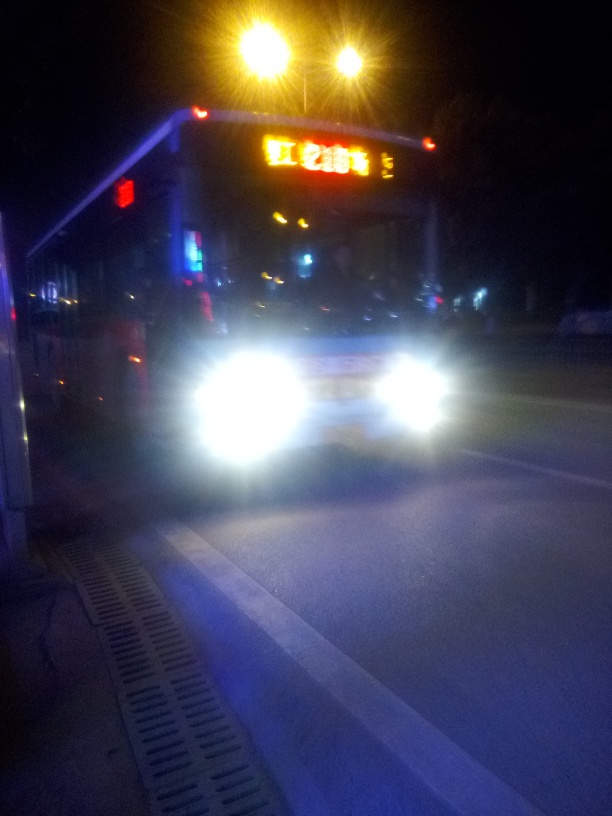Can you suggest ways this photo could have been improved? To improve the quality of this photo, a faster shutter speed could have been used to reduce motion blur. Increasing the camera's ISO setting might also help by allowing for a quicker exposure, though at the risk of more noise in the image. Additionally, steadying the camera, possibly with a tripod or by resting it on a stable surface, would ensure the image is sharper. 